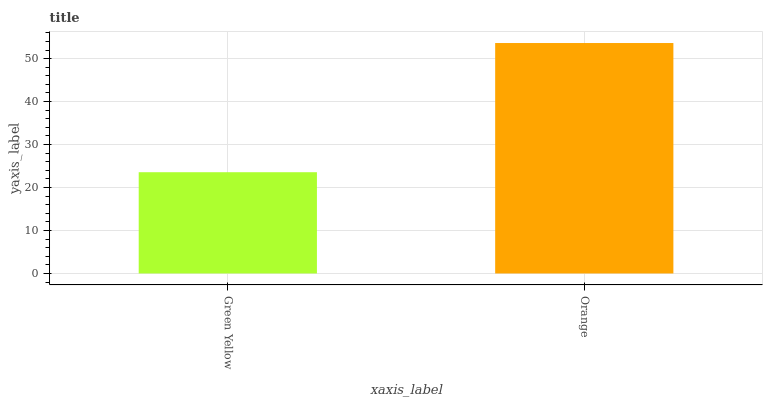Is Green Yellow the minimum?
Answer yes or no. Yes. Is Orange the maximum?
Answer yes or no. Yes. Is Orange the minimum?
Answer yes or no. No. Is Orange greater than Green Yellow?
Answer yes or no. Yes. Is Green Yellow less than Orange?
Answer yes or no. Yes. Is Green Yellow greater than Orange?
Answer yes or no. No. Is Orange less than Green Yellow?
Answer yes or no. No. Is Orange the high median?
Answer yes or no. Yes. Is Green Yellow the low median?
Answer yes or no. Yes. Is Green Yellow the high median?
Answer yes or no. No. Is Orange the low median?
Answer yes or no. No. 